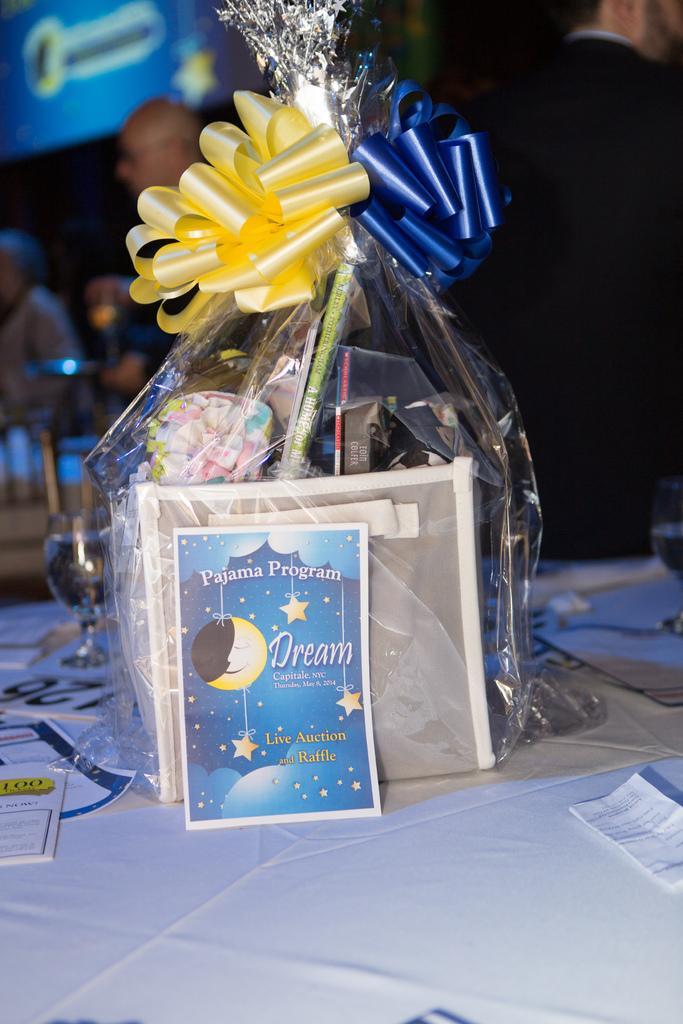How would you summarize this image in a sentence or two? In this image we can see a box and some objects inside a cover tied with the ribbons which is placed on the table. We can also see a glass, some papers with text on them and a cloth on the table. On the backside we can see a board and some people standing. 